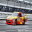The given image can contain different types of transport vehicles. People use these vehicles to travel around in their day-to-day lives. It could be air travel or a slower means of transport on the ground. Please identify the type of transport option in the picture. The vehicle shown in the photo is a high-performance race car, specifically designed and engineered for competitive motorsports. Unlike standard vehicles used for everyday travel, this race car features enhancements like an aerodynamic chassis, a powerful engine capable of high speeds, and safety modifications such as reinforced roll cages and specialized fire suppression systems. These cars are crafted for speed and efficiency on closed race tracks and are not suitable for regular road use. Excitingly, they represent the pinnacle of automotive engineering, aimed at pushing the limits of what is mechanically and dynamically possible in car racing. 